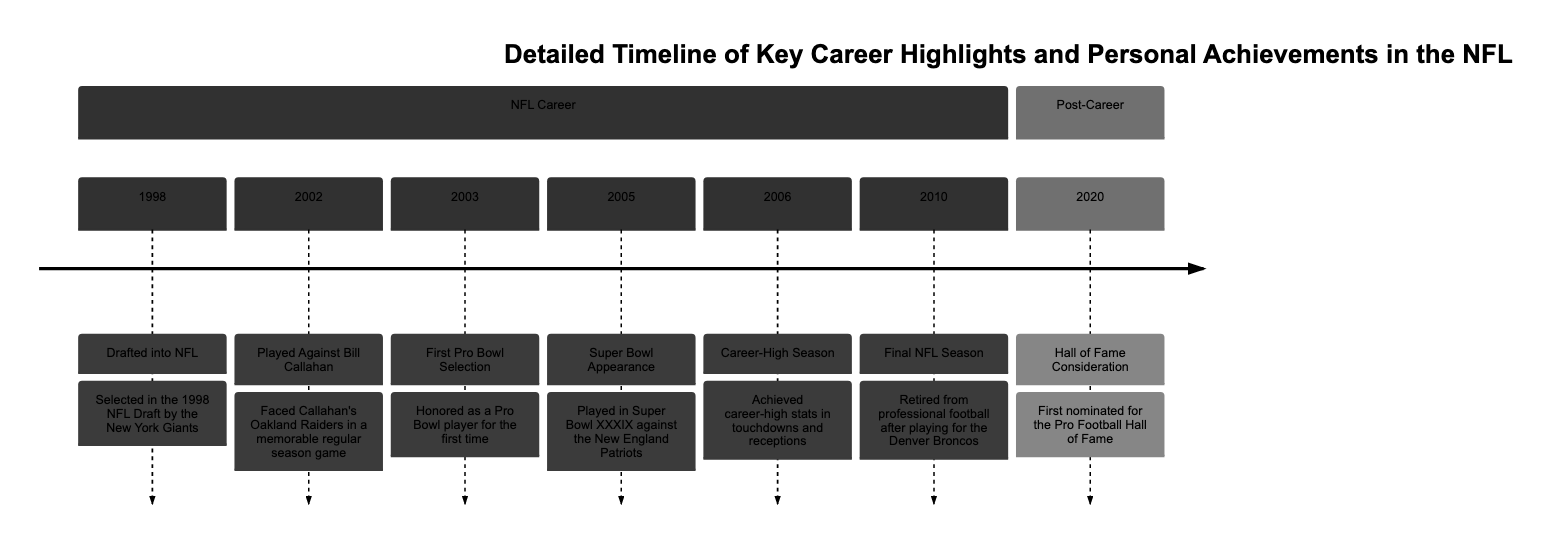What year was the player drafted into the NFL? The diagram lists "Drafted into NFL" under the NFL Career section with the year "1998." Therefore, the answer is found directly in the timeline of events.
Answer: 1998 What team did the player face Bill Callahan's team? The diagram indicates "Faced Callahan's Oakland Raiders" when describing the game in 2002. The specific team that the player played against is the Oakland Raiders.
Answer: Oakland Raiders How many Pro Bowl selections did the player have? The diagram shows a single instance of "First Pro Bowl Selection" in 2003. This indicates that the player was honored as a Pro Bowl player for the first time only once during his career, focusing on that singular achievement.
Answer: 1 In what year did the player achieve career-high stats? The timeline specifies the achievement of career-high stats in 2006, under the section for NFL Career. The event is explicitly noted with that year.
Answer: 2006 Which Super Bowl did the player participate in? The diagram mentions "Played in Super Bowl XXXIX" in the event listed for 2005 under NFL Career. This specifies the particular Super Bowl the player competed in.
Answer: Super Bowl XXXIX What event is listed for the year 2020? The diagram states "Hall of Fame Consideration" under the Post-Career section for the year 2020. This specifies the significant event that took place for the player that year.
Answer: Hall of Fame Consideration What was the player's last NFL team? The timeline states "Retired from professional football after playing for the Denver Broncos" as part of the player's career events. This clearly indicates the team the player was associated with during the final season.
Answer: Denver Broncos How many key career highlights are listed in total? Counting the events listed under the NFL Career section, there are six distinct years with events, plus one event under Post-Career, leading to seven total highlights. This counting provides the total number of highlighted career events.
Answer: 7 What major milestone happened in 2010? The diagram shows "Final NFL Season" for the year 2010, indicating that this was a significant point in the player's career as it marked the end of his time in professional football.
Answer: Final NFL Season What is the maximum achievement listed in the diagram? Considering the nature of the milestones listed, the "Hall of Fame Consideration" in 2020 is indicative of a pinnacle achievement post-career, as it reflects recognition in the form of a nomination for one of the greatest honors in professional football.
Answer: Hall of Fame Consideration 